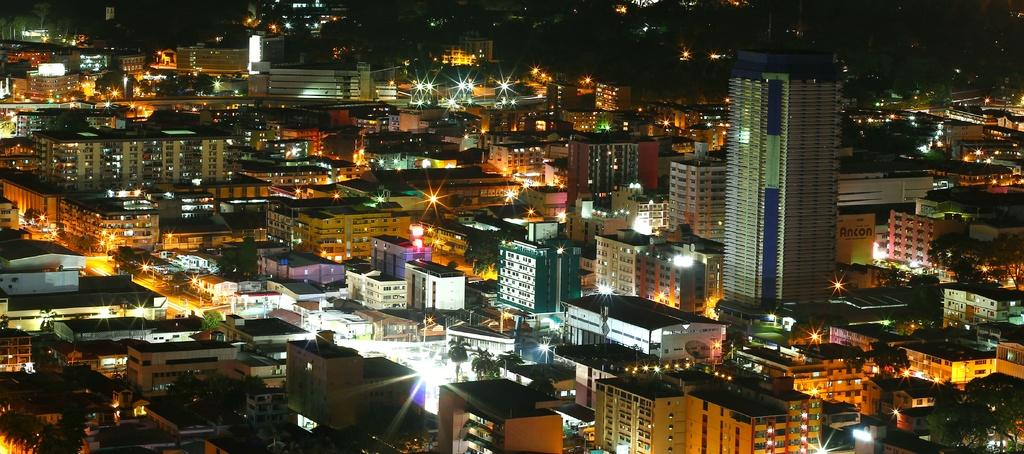What type of view is depicted in the image? The image is an aerial view. What structures can be seen from this perspective? There are buildings in the image. Are there any natural elements visible in the image? Yes, there are trees in the image. What can be observed about the lighting in the image? Lights are present in the image. How does the dock look in the image? There is no dock present in the image. Is the area depicted in the image known for its quiet atmosphere? The image does not provide information about the noise level or atmosphere of the area. 